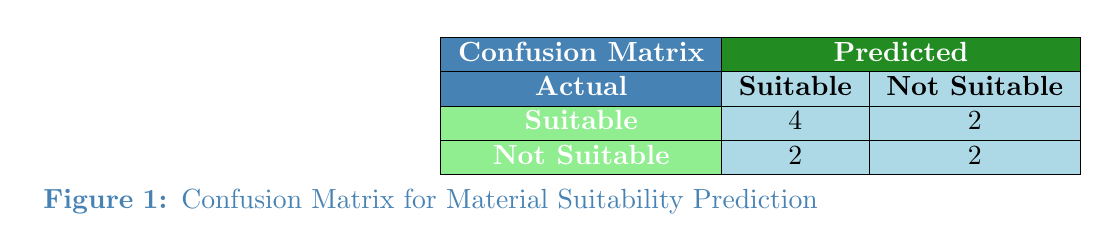What is the total number of projects predicted as suitable? In the confusion matrix under the "Predicted" column, there are 4 suitable projects labeled under "Actual" Suitable (4) and 2 labeled under "Actual" Not Suitable (in the respective Suitable prediction). Therefore, the total number of projects predicted as suitable is 4 + 2 = 6.
Answer: 6 How many projects were accurately predicted as not suitable? In the confusion matrix, under the "Actual" Not Suitable category, the predicted Not Suitable count is 2. This means that 2 projects were accurately predicted as not suitable.
Answer: 2 What percentage of suitable projects were correctly classified? In the table, there are 4 suitable projects correctly predicted as suitable (True Positives) out of a total of 6 actual suitable projects (4 true positives + 2 false negatives). The percentage will be (4 / 6) * 100 = 66.67%.
Answer: 66.67% Is it true that more than half of the predicted suitable projects were actually not suitable? In the matrix, there are 4 projects that were actually suitable but predicted as suitable, and 2 were predicted as not suitable. There are 2 incorrectly predicted (false positives). Since only 2 out of 6 predicted suitable projects were not suitable, it is false that more than half of the predicted suitable projects were actually not suitable.
Answer: No What is the ratio of correctly predicted suitable projects to the total projects in the confusion matrix? There are 4 correctly predicted suitable projects (true positives) and a total of 10 projects (sum of all rows in the matrix). Hence, the ratio is 4 / 10, which simplifies to 2:5.
Answer: 2:5 How many projects were predicted incorrectly as suitable? Looking at the confusion matrix under the "Actual" Not Suitable category, there are 2 projects that were actually not suitable but were predicted as suitable (False Positives).
Answer: 2 What is the total number of projects that were classified as suitable? The confusion matrix shows that under the predicted suitable category there are 4 true positives and 2 false positives, totaling to 4+2=6 classified as suitable.
Answer: 6 What is the difference between the number of projects accurately predicted as suitable and those accurately predicted as not suitable? The number of accurately predicted suitable projects is 4, and the number of accurately predicted not suitable projects is also 2. The difference is simply 4 - 2 = 2.
Answer: 2 